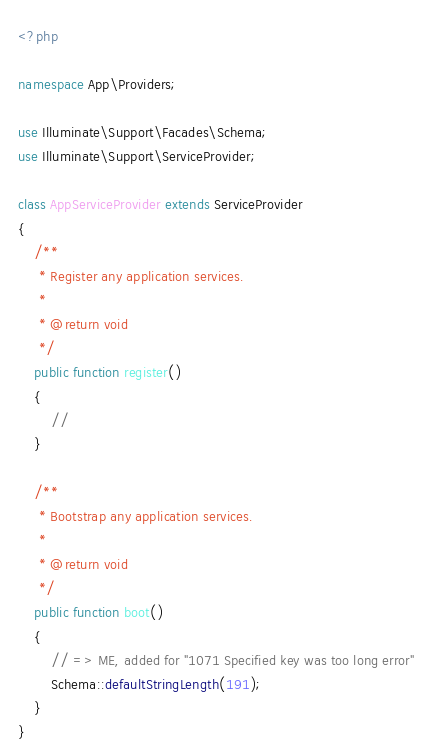Convert code to text. <code><loc_0><loc_0><loc_500><loc_500><_PHP_><?php

namespace App\Providers;

use Illuminate\Support\Facades\Schema;
use Illuminate\Support\ServiceProvider;

class AppServiceProvider extends ServiceProvider
{
    /**
     * Register any application services.
     *
     * @return void
     */
    public function register()
    {
        //
    }

    /**
     * Bootstrap any application services.
     *
     * @return void
     */
    public function boot()
    {
        // => ME, added for "1071 Specified key was too long error"
        Schema::defaultStringLength(191);
    }
}
</code> 